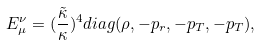<formula> <loc_0><loc_0><loc_500><loc_500>E _ { \mu } ^ { \nu } = ( \frac { \tilde { \kappa } } { \kappa } ) ^ { 4 } d i a g ( \rho , - p _ { r } , - p _ { T } , - p _ { T } ) ,</formula> 